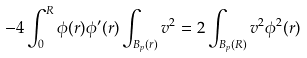Convert formula to latex. <formula><loc_0><loc_0><loc_500><loc_500>- 4 \int _ { 0 } ^ { R } \phi ( r ) \phi ^ { \prime } ( r ) \int _ { B _ { p } ( r ) } v ^ { 2 } = 2 \int _ { B _ { p } ( R ) } v ^ { 2 } \phi ^ { 2 } ( r )</formula> 